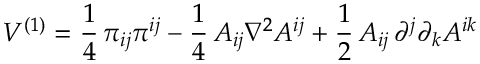Convert formula to latex. <formula><loc_0><loc_0><loc_500><loc_500>V ^ { ( 1 ) } = \frac { 1 } { 4 } \, \pi _ { i j } \pi ^ { i j } - \frac { 1 } { 4 } \, A _ { i j } \nabla ^ { 2 } A ^ { i j } + \frac { 1 } { 2 } \, A _ { i j } \, \partial ^ { j } \partial _ { k } A ^ { i k }</formula> 